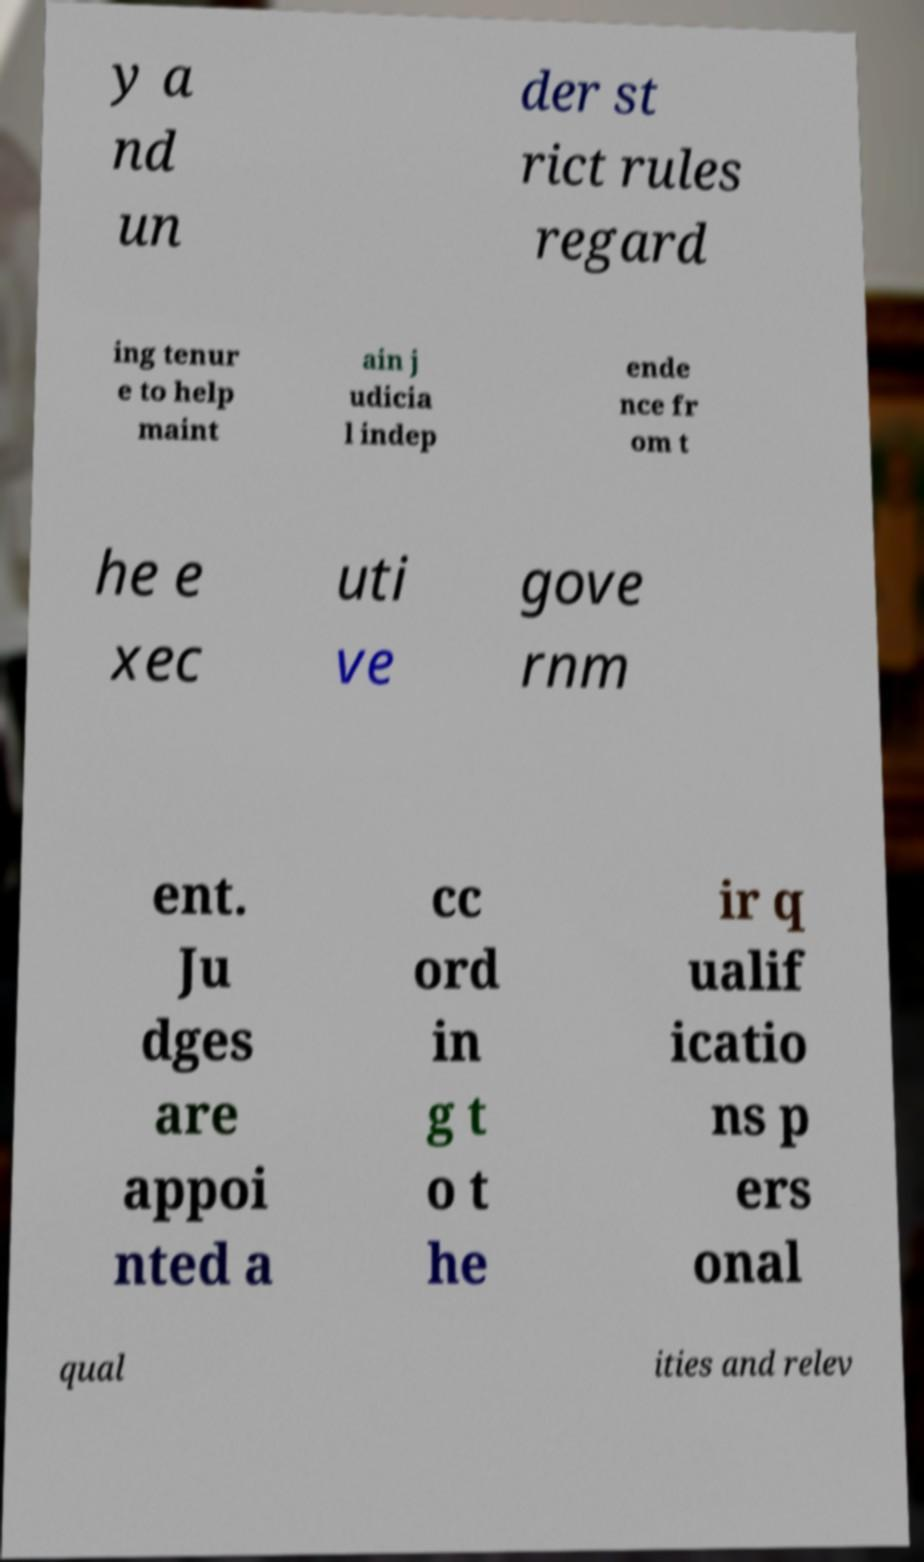Could you extract and type out the text from this image? y a nd un der st rict rules regard ing tenur e to help maint ain j udicia l indep ende nce fr om t he e xec uti ve gove rnm ent. Ju dges are appoi nted a cc ord in g t o t he ir q ualif icatio ns p ers onal qual ities and relev 